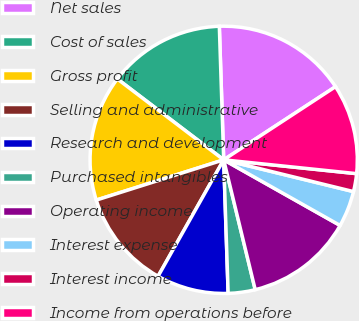Convert chart to OTSL. <chart><loc_0><loc_0><loc_500><loc_500><pie_chart><fcel>Net sales<fcel>Cost of sales<fcel>Gross profit<fcel>Selling and administrative<fcel>Research and development<fcel>Purchased intangibles<fcel>Operating income<fcel>Interest expense<fcel>Interest income<fcel>Income from operations before<nl><fcel>16.3%<fcel>14.13%<fcel>15.22%<fcel>11.96%<fcel>8.7%<fcel>3.26%<fcel>13.04%<fcel>4.35%<fcel>2.17%<fcel>10.87%<nl></chart> 